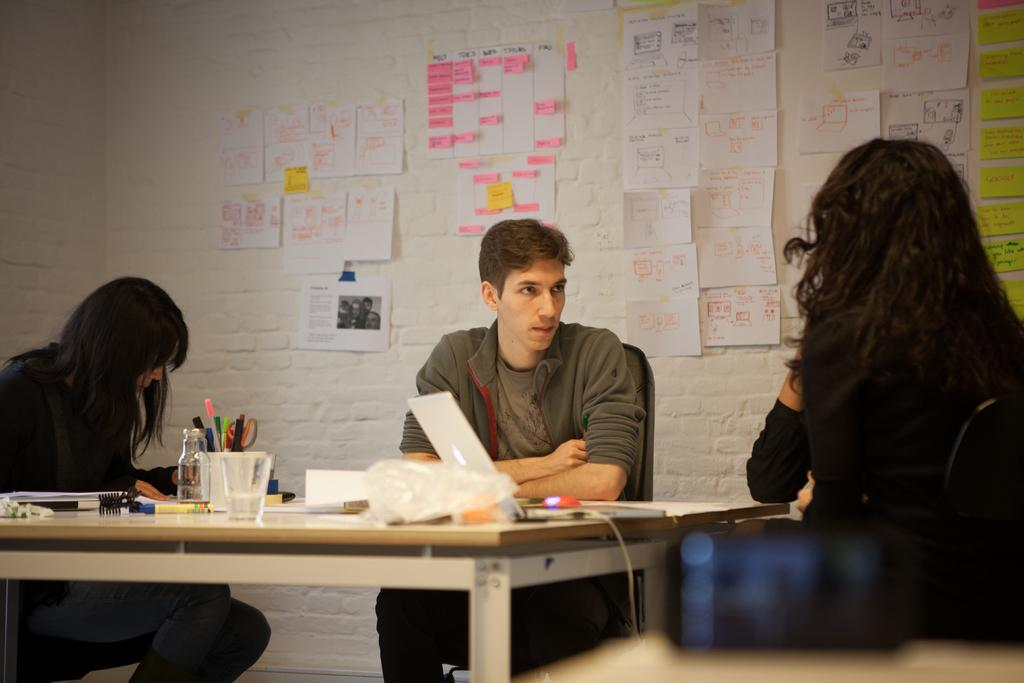How many people are sitting on the chair in the image? There are three people sitting on a chair in the image. What is present on the table in the image? There is a pen box, a glass, a sketch, and a laptop on the table in the image. What might the people be using the pen box for? The pen box might be used for storing pens or other writing instruments. What is the purpose of the glass on the table? The glass might be used for holding a beverage or for other purposes. What type of mark can be seen on the sketch in the image? There is no specific mark mentioned in the facts, and therefore we cannot determine the type of mark on the sketch. How many beds are visible in the image? There are no beds visible in the image; it features a chair with three people sitting on it and a table with various items. 